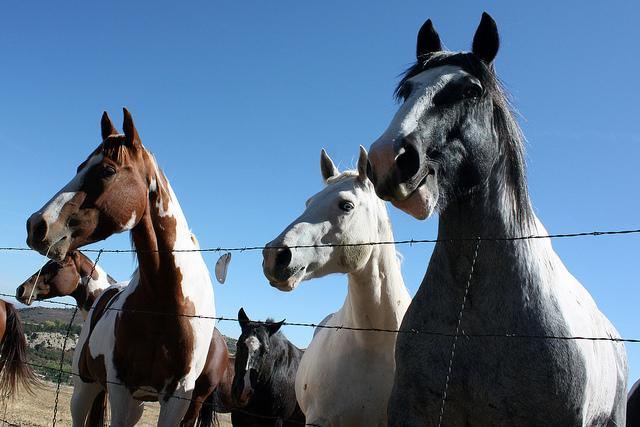What kind of fencing is used around these horses to keep them confined? Please explain your reasoning. electrified. Horses are standing by a barbed wired fence that will shock them if they try to escape. 